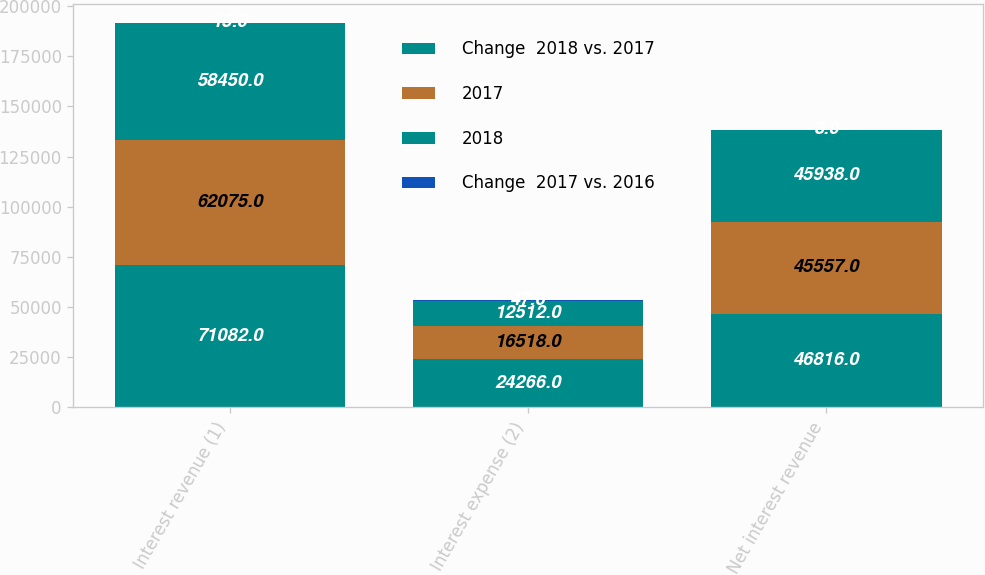Convert chart to OTSL. <chart><loc_0><loc_0><loc_500><loc_500><stacked_bar_chart><ecel><fcel>Interest revenue (1)<fcel>Interest expense (2)<fcel>Net interest revenue<nl><fcel>Change  2018 vs. 2017<fcel>71082<fcel>24266<fcel>46816<nl><fcel>2017<fcel>62075<fcel>16518<fcel>45557<nl><fcel>2018<fcel>58450<fcel>12512<fcel>45938<nl><fcel>Change  2017 vs. 2016<fcel>15<fcel>47<fcel>3<nl></chart> 